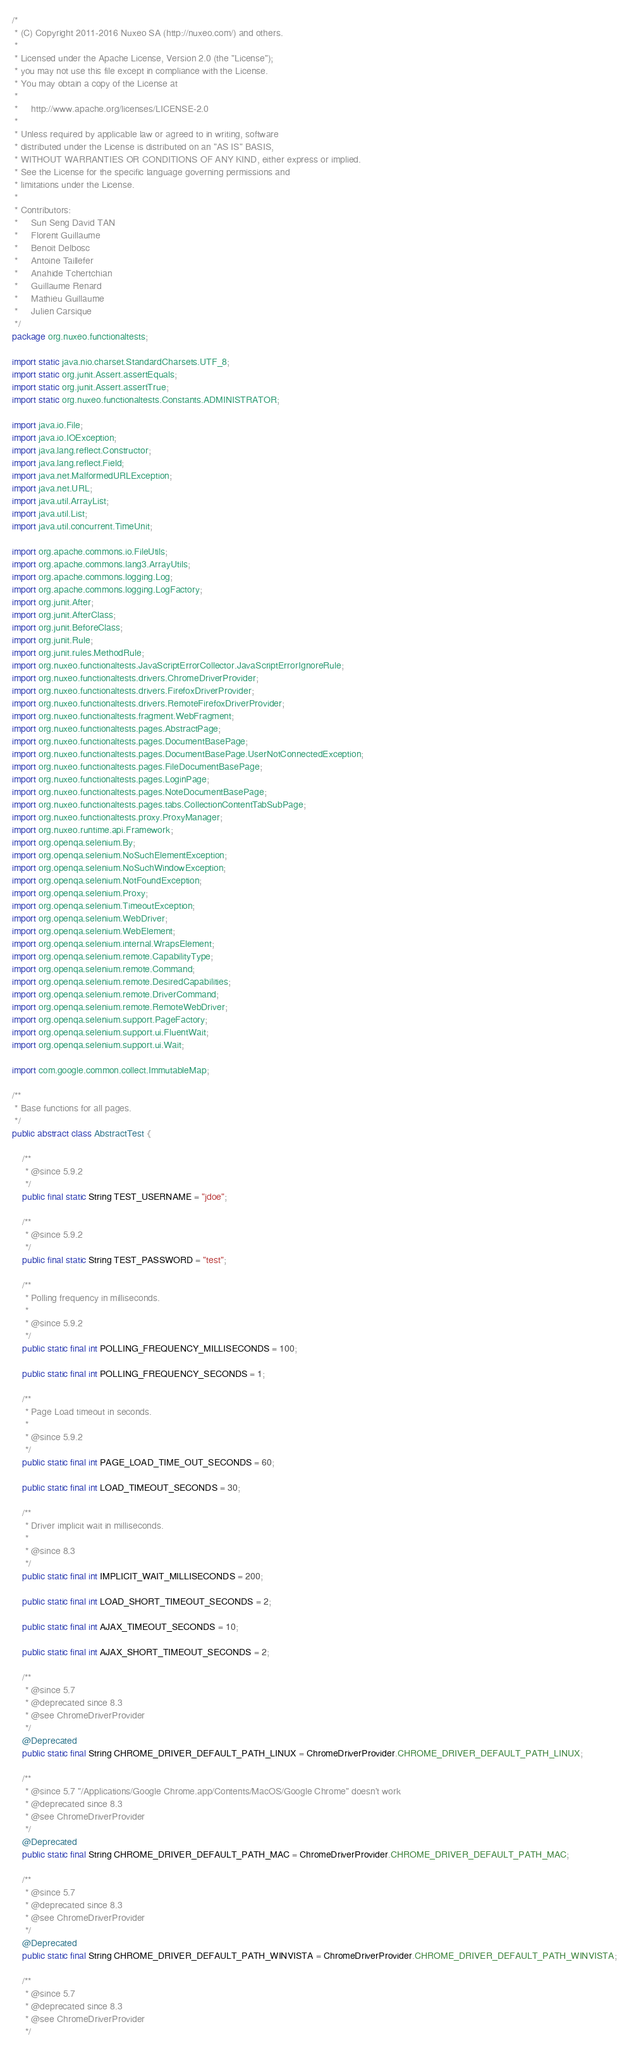<code> <loc_0><loc_0><loc_500><loc_500><_Java_>/*
 * (C) Copyright 2011-2016 Nuxeo SA (http://nuxeo.com/) and others.
 *
 * Licensed under the Apache License, Version 2.0 (the "License");
 * you may not use this file except in compliance with the License.
 * You may obtain a copy of the License at
 *
 *     http://www.apache.org/licenses/LICENSE-2.0
 *
 * Unless required by applicable law or agreed to in writing, software
 * distributed under the License is distributed on an "AS IS" BASIS,
 * WITHOUT WARRANTIES OR CONDITIONS OF ANY KIND, either express or implied.
 * See the License for the specific language governing permissions and
 * limitations under the License.
 *
 * Contributors:
 *     Sun Seng David TAN
 *     Florent Guillaume
 *     Benoit Delbosc
 *     Antoine Taillefer
 *     Anahide Tchertchian
 *     Guillaume Renard
 *     Mathieu Guillaume
 *     Julien Carsique
 */
package org.nuxeo.functionaltests;

import static java.nio.charset.StandardCharsets.UTF_8;
import static org.junit.Assert.assertEquals;
import static org.junit.Assert.assertTrue;
import static org.nuxeo.functionaltests.Constants.ADMINISTRATOR;

import java.io.File;
import java.io.IOException;
import java.lang.reflect.Constructor;
import java.lang.reflect.Field;
import java.net.MalformedURLException;
import java.net.URL;
import java.util.ArrayList;
import java.util.List;
import java.util.concurrent.TimeUnit;

import org.apache.commons.io.FileUtils;
import org.apache.commons.lang3.ArrayUtils;
import org.apache.commons.logging.Log;
import org.apache.commons.logging.LogFactory;
import org.junit.After;
import org.junit.AfterClass;
import org.junit.BeforeClass;
import org.junit.Rule;
import org.junit.rules.MethodRule;
import org.nuxeo.functionaltests.JavaScriptErrorCollector.JavaScriptErrorIgnoreRule;
import org.nuxeo.functionaltests.drivers.ChromeDriverProvider;
import org.nuxeo.functionaltests.drivers.FirefoxDriverProvider;
import org.nuxeo.functionaltests.drivers.RemoteFirefoxDriverProvider;
import org.nuxeo.functionaltests.fragment.WebFragment;
import org.nuxeo.functionaltests.pages.AbstractPage;
import org.nuxeo.functionaltests.pages.DocumentBasePage;
import org.nuxeo.functionaltests.pages.DocumentBasePage.UserNotConnectedException;
import org.nuxeo.functionaltests.pages.FileDocumentBasePage;
import org.nuxeo.functionaltests.pages.LoginPage;
import org.nuxeo.functionaltests.pages.NoteDocumentBasePage;
import org.nuxeo.functionaltests.pages.tabs.CollectionContentTabSubPage;
import org.nuxeo.functionaltests.proxy.ProxyManager;
import org.nuxeo.runtime.api.Framework;
import org.openqa.selenium.By;
import org.openqa.selenium.NoSuchElementException;
import org.openqa.selenium.NoSuchWindowException;
import org.openqa.selenium.NotFoundException;
import org.openqa.selenium.Proxy;
import org.openqa.selenium.TimeoutException;
import org.openqa.selenium.WebDriver;
import org.openqa.selenium.WebElement;
import org.openqa.selenium.internal.WrapsElement;
import org.openqa.selenium.remote.CapabilityType;
import org.openqa.selenium.remote.Command;
import org.openqa.selenium.remote.DesiredCapabilities;
import org.openqa.selenium.remote.DriverCommand;
import org.openqa.selenium.remote.RemoteWebDriver;
import org.openqa.selenium.support.PageFactory;
import org.openqa.selenium.support.ui.FluentWait;
import org.openqa.selenium.support.ui.Wait;

import com.google.common.collect.ImmutableMap;

/**
 * Base functions for all pages.
 */
public abstract class AbstractTest {

    /**
     * @since 5.9.2
     */
    public final static String TEST_USERNAME = "jdoe";

    /**
     * @since 5.9.2
     */
    public final static String TEST_PASSWORD = "test";

    /**
     * Polling frequency in milliseconds.
     *
     * @since 5.9.2
     */
    public static final int POLLING_FREQUENCY_MILLISECONDS = 100;

    public static final int POLLING_FREQUENCY_SECONDS = 1;

    /**
     * Page Load timeout in seconds.
     *
     * @since 5.9.2
     */
    public static final int PAGE_LOAD_TIME_OUT_SECONDS = 60;

    public static final int LOAD_TIMEOUT_SECONDS = 30;

    /**
     * Driver implicit wait in milliseconds.
     *
     * @since 8.3
     */
    public static final int IMPLICIT_WAIT_MILLISECONDS = 200;

    public static final int LOAD_SHORT_TIMEOUT_SECONDS = 2;

    public static final int AJAX_TIMEOUT_SECONDS = 10;

    public static final int AJAX_SHORT_TIMEOUT_SECONDS = 2;

    /**
     * @since 5.7
     * @deprecated since 8.3
     * @see ChromeDriverProvider
     */
    @Deprecated
    public static final String CHROME_DRIVER_DEFAULT_PATH_LINUX = ChromeDriverProvider.CHROME_DRIVER_DEFAULT_PATH_LINUX;

    /**
     * @since 5.7 "/Applications/Google Chrome.app/Contents/MacOS/Google Chrome" doesn't work
     * @deprecated since 8.3
     * @see ChromeDriverProvider
     */
    @Deprecated
    public static final String CHROME_DRIVER_DEFAULT_PATH_MAC = ChromeDriverProvider.CHROME_DRIVER_DEFAULT_PATH_MAC;

    /**
     * @since 5.7
     * @deprecated since 8.3
     * @see ChromeDriverProvider
     */
    @Deprecated
    public static final String CHROME_DRIVER_DEFAULT_PATH_WINVISTA = ChromeDriverProvider.CHROME_DRIVER_DEFAULT_PATH_WINVISTA;

    /**
     * @since 5.7
     * @deprecated since 8.3
     * @see ChromeDriverProvider
     */</code> 